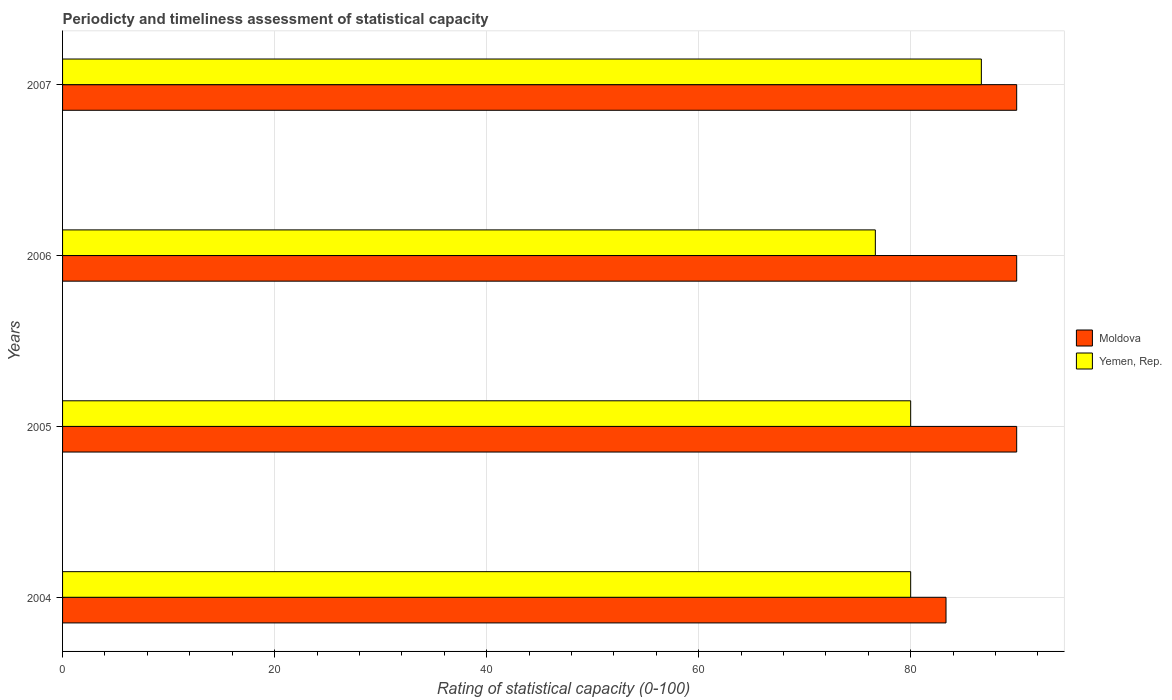How many groups of bars are there?
Give a very brief answer. 4. How many bars are there on the 4th tick from the top?
Offer a terse response. 2. How many bars are there on the 3rd tick from the bottom?
Offer a terse response. 2. What is the rating of statistical capacity in Yemen, Rep. in 2007?
Your answer should be very brief. 86.67. Across all years, what is the minimum rating of statistical capacity in Yemen, Rep.?
Provide a short and direct response. 76.67. In which year was the rating of statistical capacity in Moldova maximum?
Your answer should be compact. 2005. What is the total rating of statistical capacity in Moldova in the graph?
Give a very brief answer. 353.33. What is the difference between the rating of statistical capacity in Yemen, Rep. in 2005 and that in 2006?
Provide a succinct answer. 3.33. What is the difference between the rating of statistical capacity in Yemen, Rep. in 2004 and the rating of statistical capacity in Moldova in 2006?
Your answer should be compact. -10. What is the average rating of statistical capacity in Yemen, Rep. per year?
Your answer should be compact. 80.83. In the year 2006, what is the difference between the rating of statistical capacity in Moldova and rating of statistical capacity in Yemen, Rep.?
Your response must be concise. 13.33. What is the ratio of the rating of statistical capacity in Yemen, Rep. in 2004 to that in 2007?
Provide a short and direct response. 0.92. Is the rating of statistical capacity in Moldova in 2006 less than that in 2007?
Your answer should be very brief. No. What is the difference between the highest and the second highest rating of statistical capacity in Yemen, Rep.?
Your response must be concise. 6.67. What is the difference between the highest and the lowest rating of statistical capacity in Moldova?
Make the answer very short. 6.67. Is the sum of the rating of statistical capacity in Yemen, Rep. in 2006 and 2007 greater than the maximum rating of statistical capacity in Moldova across all years?
Ensure brevity in your answer.  Yes. What does the 1st bar from the top in 2004 represents?
Keep it short and to the point. Yemen, Rep. What does the 1st bar from the bottom in 2005 represents?
Provide a succinct answer. Moldova. How many bars are there?
Ensure brevity in your answer.  8. Are all the bars in the graph horizontal?
Ensure brevity in your answer.  Yes. Where does the legend appear in the graph?
Give a very brief answer. Center right. How many legend labels are there?
Give a very brief answer. 2. What is the title of the graph?
Offer a very short reply. Periodicty and timeliness assessment of statistical capacity. What is the label or title of the X-axis?
Keep it short and to the point. Rating of statistical capacity (0-100). What is the label or title of the Y-axis?
Give a very brief answer. Years. What is the Rating of statistical capacity (0-100) in Moldova in 2004?
Offer a very short reply. 83.33. What is the Rating of statistical capacity (0-100) in Yemen, Rep. in 2004?
Keep it short and to the point. 80. What is the Rating of statistical capacity (0-100) of Yemen, Rep. in 2006?
Make the answer very short. 76.67. What is the Rating of statistical capacity (0-100) in Moldova in 2007?
Offer a terse response. 90. What is the Rating of statistical capacity (0-100) in Yemen, Rep. in 2007?
Ensure brevity in your answer.  86.67. Across all years, what is the maximum Rating of statistical capacity (0-100) in Yemen, Rep.?
Keep it short and to the point. 86.67. Across all years, what is the minimum Rating of statistical capacity (0-100) in Moldova?
Your answer should be compact. 83.33. Across all years, what is the minimum Rating of statistical capacity (0-100) in Yemen, Rep.?
Your answer should be compact. 76.67. What is the total Rating of statistical capacity (0-100) of Moldova in the graph?
Offer a very short reply. 353.33. What is the total Rating of statistical capacity (0-100) of Yemen, Rep. in the graph?
Provide a succinct answer. 323.33. What is the difference between the Rating of statistical capacity (0-100) in Moldova in 2004 and that in 2005?
Your answer should be compact. -6.67. What is the difference between the Rating of statistical capacity (0-100) of Yemen, Rep. in 2004 and that in 2005?
Give a very brief answer. 0. What is the difference between the Rating of statistical capacity (0-100) in Moldova in 2004 and that in 2006?
Ensure brevity in your answer.  -6.67. What is the difference between the Rating of statistical capacity (0-100) of Moldova in 2004 and that in 2007?
Make the answer very short. -6.67. What is the difference between the Rating of statistical capacity (0-100) in Yemen, Rep. in 2004 and that in 2007?
Make the answer very short. -6.67. What is the difference between the Rating of statistical capacity (0-100) in Moldova in 2005 and that in 2007?
Ensure brevity in your answer.  0. What is the difference between the Rating of statistical capacity (0-100) in Yemen, Rep. in 2005 and that in 2007?
Your answer should be compact. -6.67. What is the difference between the Rating of statistical capacity (0-100) in Moldova in 2006 and that in 2007?
Your answer should be compact. 0. What is the difference between the Rating of statistical capacity (0-100) in Yemen, Rep. in 2006 and that in 2007?
Your response must be concise. -10. What is the difference between the Rating of statistical capacity (0-100) in Moldova in 2004 and the Rating of statistical capacity (0-100) in Yemen, Rep. in 2006?
Offer a terse response. 6.67. What is the difference between the Rating of statistical capacity (0-100) in Moldova in 2005 and the Rating of statistical capacity (0-100) in Yemen, Rep. in 2006?
Offer a very short reply. 13.33. What is the difference between the Rating of statistical capacity (0-100) of Moldova in 2005 and the Rating of statistical capacity (0-100) of Yemen, Rep. in 2007?
Provide a succinct answer. 3.33. What is the average Rating of statistical capacity (0-100) of Moldova per year?
Your answer should be compact. 88.33. What is the average Rating of statistical capacity (0-100) in Yemen, Rep. per year?
Give a very brief answer. 80.83. In the year 2006, what is the difference between the Rating of statistical capacity (0-100) of Moldova and Rating of statistical capacity (0-100) of Yemen, Rep.?
Your answer should be very brief. 13.33. In the year 2007, what is the difference between the Rating of statistical capacity (0-100) in Moldova and Rating of statistical capacity (0-100) in Yemen, Rep.?
Your answer should be compact. 3.33. What is the ratio of the Rating of statistical capacity (0-100) in Moldova in 2004 to that in 2005?
Provide a short and direct response. 0.93. What is the ratio of the Rating of statistical capacity (0-100) of Yemen, Rep. in 2004 to that in 2005?
Your response must be concise. 1. What is the ratio of the Rating of statistical capacity (0-100) in Moldova in 2004 to that in 2006?
Give a very brief answer. 0.93. What is the ratio of the Rating of statistical capacity (0-100) in Yemen, Rep. in 2004 to that in 2006?
Your answer should be very brief. 1.04. What is the ratio of the Rating of statistical capacity (0-100) in Moldova in 2004 to that in 2007?
Provide a short and direct response. 0.93. What is the ratio of the Rating of statistical capacity (0-100) in Moldova in 2005 to that in 2006?
Your response must be concise. 1. What is the ratio of the Rating of statistical capacity (0-100) in Yemen, Rep. in 2005 to that in 2006?
Make the answer very short. 1.04. What is the ratio of the Rating of statistical capacity (0-100) in Moldova in 2005 to that in 2007?
Give a very brief answer. 1. What is the ratio of the Rating of statistical capacity (0-100) in Yemen, Rep. in 2006 to that in 2007?
Your answer should be very brief. 0.88. 